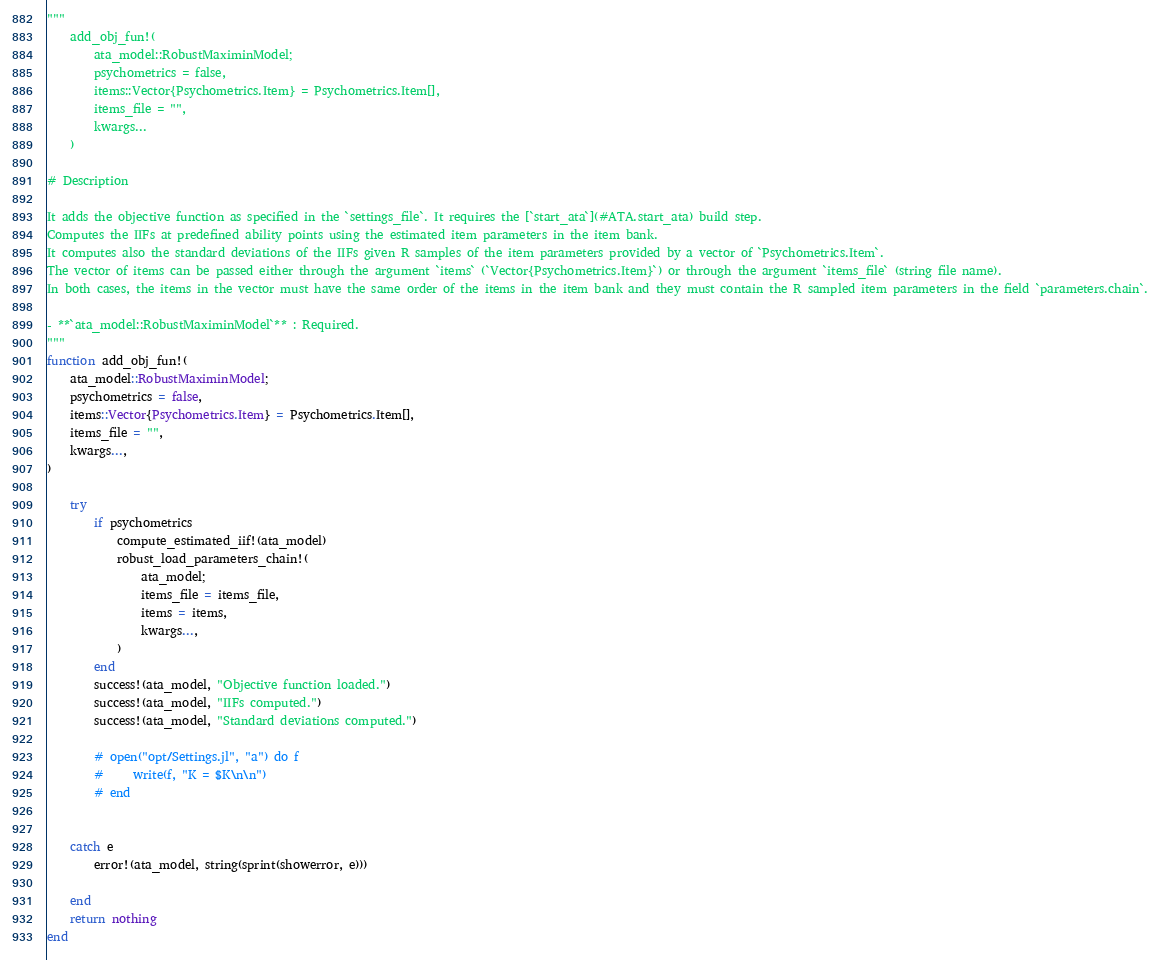Convert code to text. <code><loc_0><loc_0><loc_500><loc_500><_Julia_>"""
    add_obj_fun!(
        ata_model::RobustMaximinModel;
        psychometrics = false,
        items::Vector{Psychometrics.Item} = Psychometrics.Item[],
        items_file = "",
        kwargs...
    )

# Description

It adds the objective function as specified in the `settings_file`. It requires the [`start_ata`](#ATA.start_ata) build step.  
Computes the IIFs at predefined ability points using the estimated item parameters in the item bank.
It computes also the standard deviations of the IIFs given R samples of the item parameters provided by a vector of `Psychometrics.Item`.
The vector of items can be passed either through the argument `items` (`Vector{Psychometrics.Item}`) or through the argument `items_file` (string file name).
In both cases, the items in the vector must have the same order of the items in the item bank and they must contain the R sampled item parameters in the field `parameters.chain`.

- **`ata_model::RobustMaximinModel`** : Required.
"""
function add_obj_fun!(
    ata_model::RobustMaximinModel;
    psychometrics = false,
    items::Vector{Psychometrics.Item} = Psychometrics.Item[],
    items_file = "",
    kwargs...,
)

    try
        if psychometrics
            compute_estimated_iif!(ata_model)
            robust_load_parameters_chain!(
                ata_model;
                items_file = items_file,
                items = items,
                kwargs...,
            )
        end
        success!(ata_model, "Objective function loaded.")
        success!(ata_model, "IIFs computed.")
        success!(ata_model, "Standard deviations computed.")

        # open("opt/Settings.jl", "a") do f
        #     write(f, "K = $K\n\n")
        # end


    catch e
        error!(ata_model, string(sprint(showerror, e)))

    end
    return nothing
end
</code> 